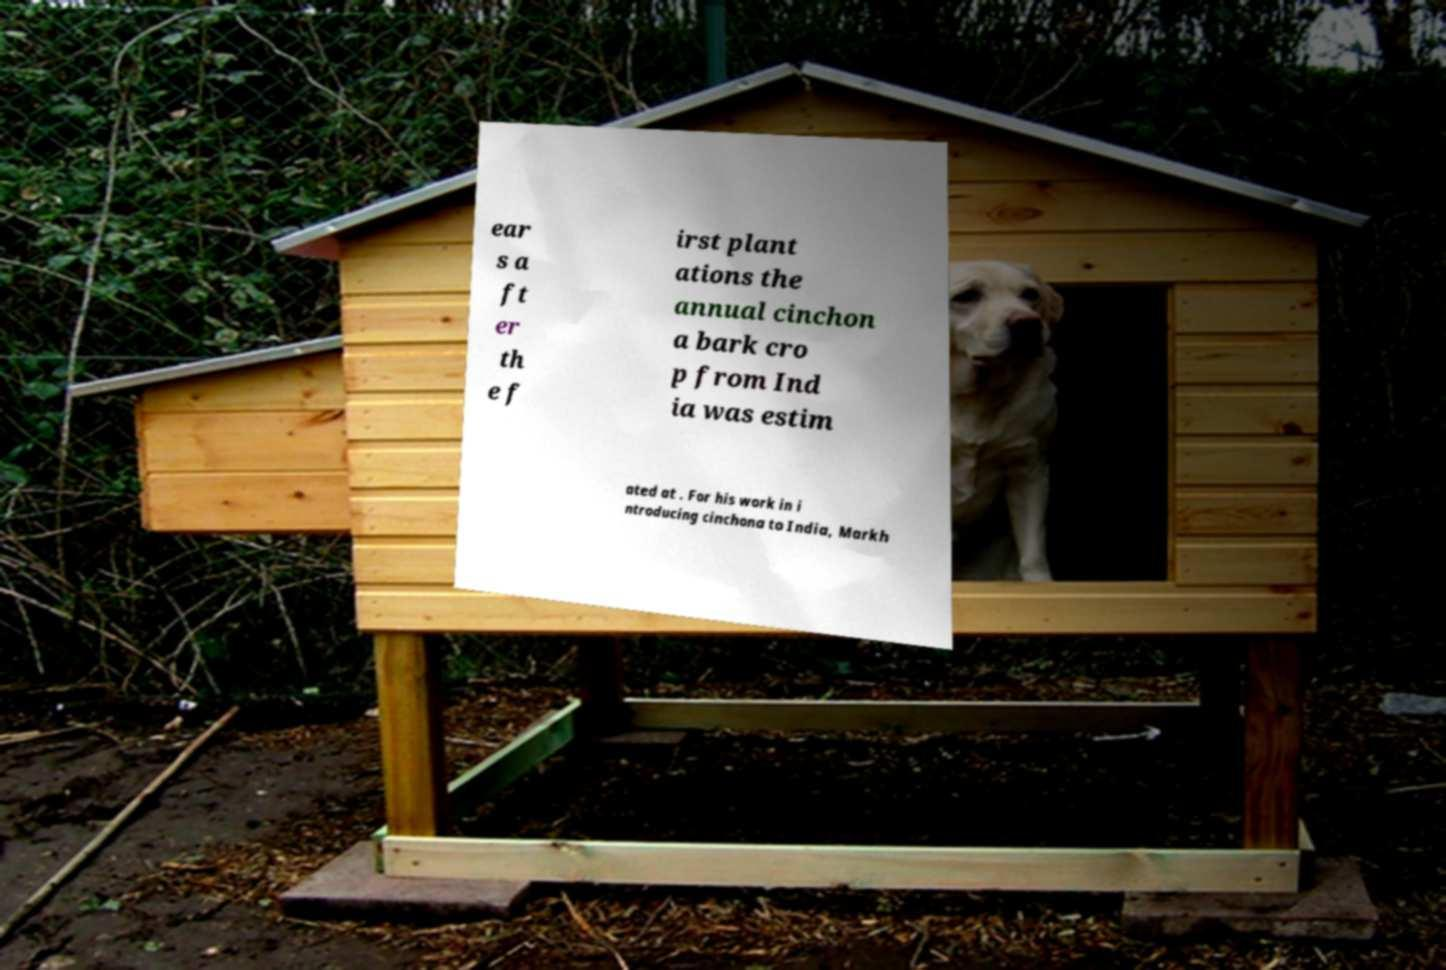Can you accurately transcribe the text from the provided image for me? ear s a ft er th e f irst plant ations the annual cinchon a bark cro p from Ind ia was estim ated at . For his work in i ntroducing cinchona to India, Markh 